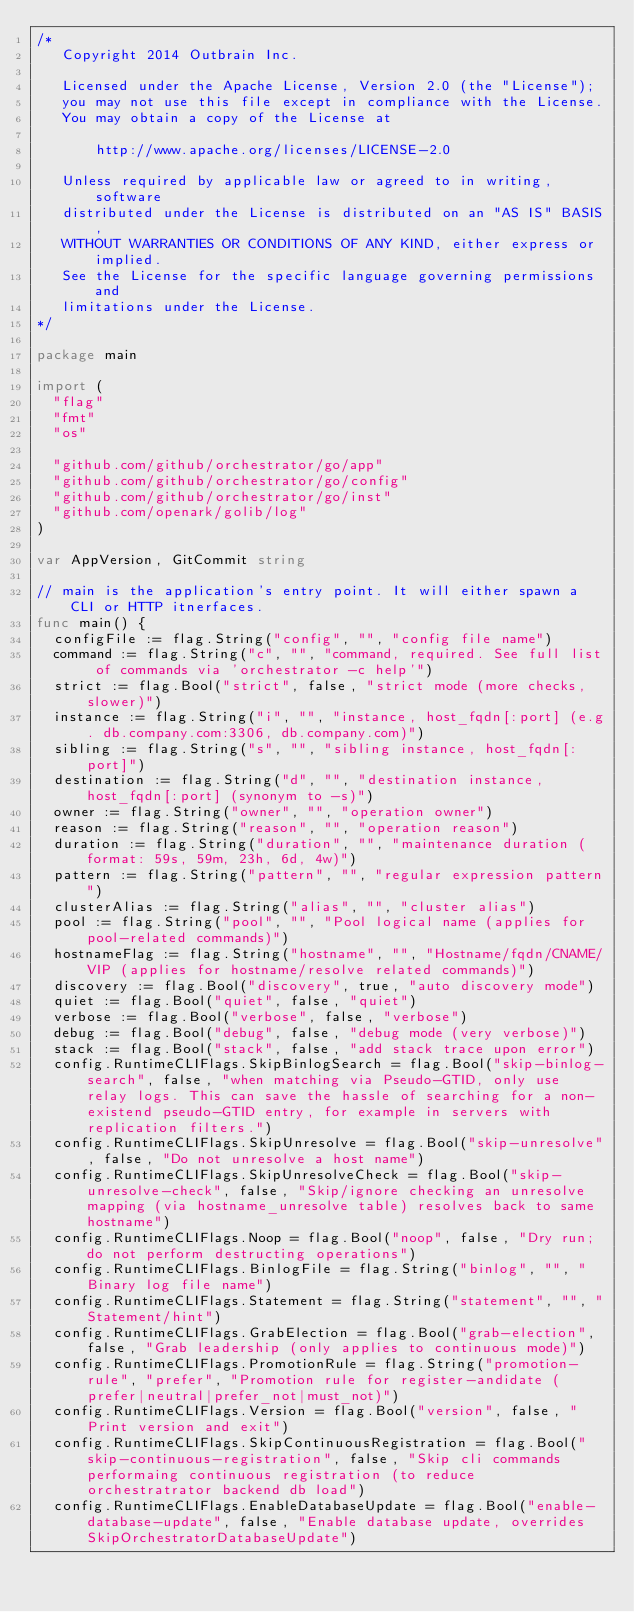Convert code to text. <code><loc_0><loc_0><loc_500><loc_500><_Go_>/*
   Copyright 2014 Outbrain Inc.

   Licensed under the Apache License, Version 2.0 (the "License");
   you may not use this file except in compliance with the License.
   You may obtain a copy of the License at

       http://www.apache.org/licenses/LICENSE-2.0

   Unless required by applicable law or agreed to in writing, software
   distributed under the License is distributed on an "AS IS" BASIS,
   WITHOUT WARRANTIES OR CONDITIONS OF ANY KIND, either express or implied.
   See the License for the specific language governing permissions and
   limitations under the License.
*/

package main

import (
	"flag"
	"fmt"
	"os"

	"github.com/github/orchestrator/go/app"
	"github.com/github/orchestrator/go/config"
	"github.com/github/orchestrator/go/inst"
	"github.com/openark/golib/log"
)

var AppVersion, GitCommit string

// main is the application's entry point. It will either spawn a CLI or HTTP itnerfaces.
func main() {
	configFile := flag.String("config", "", "config file name")
	command := flag.String("c", "", "command, required. See full list of commands via 'orchestrator -c help'")
	strict := flag.Bool("strict", false, "strict mode (more checks, slower)")
	instance := flag.String("i", "", "instance, host_fqdn[:port] (e.g. db.company.com:3306, db.company.com)")
	sibling := flag.String("s", "", "sibling instance, host_fqdn[:port]")
	destination := flag.String("d", "", "destination instance, host_fqdn[:port] (synonym to -s)")
	owner := flag.String("owner", "", "operation owner")
	reason := flag.String("reason", "", "operation reason")
	duration := flag.String("duration", "", "maintenance duration (format: 59s, 59m, 23h, 6d, 4w)")
	pattern := flag.String("pattern", "", "regular expression pattern")
	clusterAlias := flag.String("alias", "", "cluster alias")
	pool := flag.String("pool", "", "Pool logical name (applies for pool-related commands)")
	hostnameFlag := flag.String("hostname", "", "Hostname/fqdn/CNAME/VIP (applies for hostname/resolve related commands)")
	discovery := flag.Bool("discovery", true, "auto discovery mode")
	quiet := flag.Bool("quiet", false, "quiet")
	verbose := flag.Bool("verbose", false, "verbose")
	debug := flag.Bool("debug", false, "debug mode (very verbose)")
	stack := flag.Bool("stack", false, "add stack trace upon error")
	config.RuntimeCLIFlags.SkipBinlogSearch = flag.Bool("skip-binlog-search", false, "when matching via Pseudo-GTID, only use relay logs. This can save the hassle of searching for a non-existend pseudo-GTID entry, for example in servers with replication filters.")
	config.RuntimeCLIFlags.SkipUnresolve = flag.Bool("skip-unresolve", false, "Do not unresolve a host name")
	config.RuntimeCLIFlags.SkipUnresolveCheck = flag.Bool("skip-unresolve-check", false, "Skip/ignore checking an unresolve mapping (via hostname_unresolve table) resolves back to same hostname")
	config.RuntimeCLIFlags.Noop = flag.Bool("noop", false, "Dry run; do not perform destructing operations")
	config.RuntimeCLIFlags.BinlogFile = flag.String("binlog", "", "Binary log file name")
	config.RuntimeCLIFlags.Statement = flag.String("statement", "", "Statement/hint")
	config.RuntimeCLIFlags.GrabElection = flag.Bool("grab-election", false, "Grab leadership (only applies to continuous mode)")
	config.RuntimeCLIFlags.PromotionRule = flag.String("promotion-rule", "prefer", "Promotion rule for register-andidate (prefer|neutral|prefer_not|must_not)")
	config.RuntimeCLIFlags.Version = flag.Bool("version", false, "Print version and exit")
	config.RuntimeCLIFlags.SkipContinuousRegistration = flag.Bool("skip-continuous-registration", false, "Skip cli commands performaing continuous registration (to reduce orchestratrator backend db load")
	config.RuntimeCLIFlags.EnableDatabaseUpdate = flag.Bool("enable-database-update", false, "Enable database update, overrides SkipOrchestratorDatabaseUpdate")</code> 